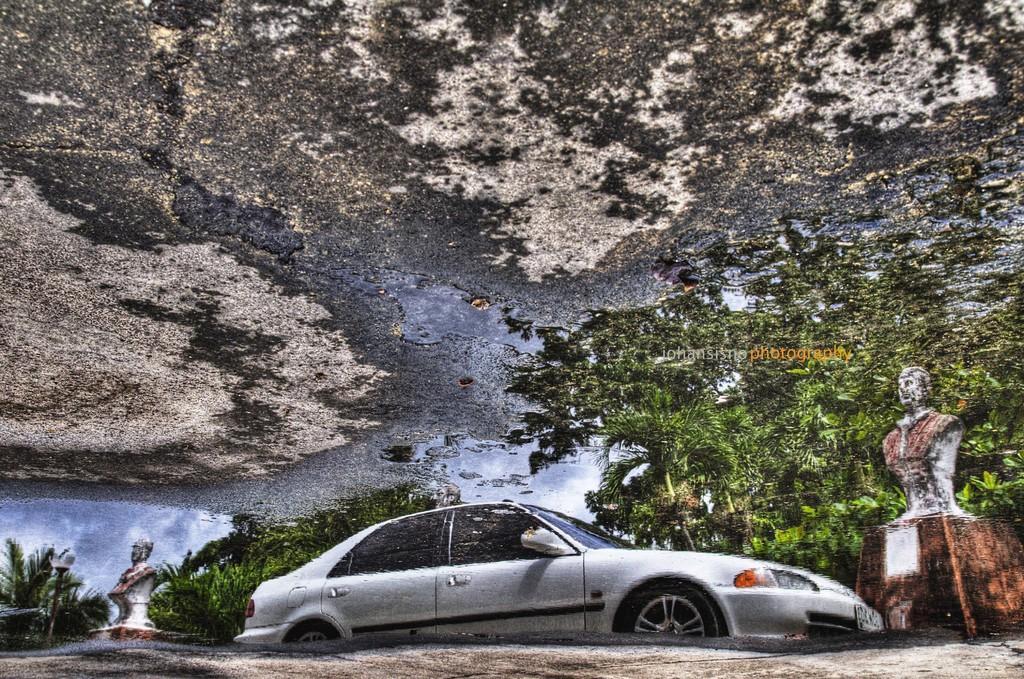Can you describe this image briefly? In this picture, we see a car. There are three statues. Behind that, there are trees. At the top of the picture, we see the land which is covered with grass. This might be an edited image. 